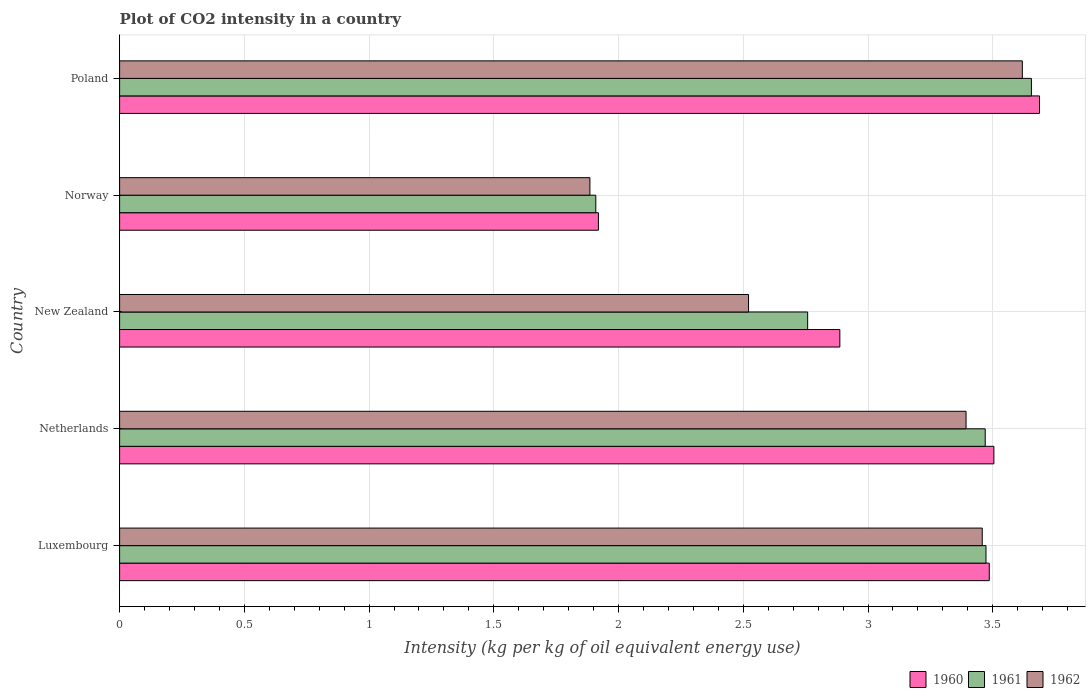How many different coloured bars are there?
Give a very brief answer. 3. How many bars are there on the 3rd tick from the bottom?
Ensure brevity in your answer.  3. What is the label of the 2nd group of bars from the top?
Offer a terse response. Norway. What is the CO2 intensity in in 1960 in New Zealand?
Your response must be concise. 2.89. Across all countries, what is the maximum CO2 intensity in in 1962?
Offer a very short reply. 3.62. Across all countries, what is the minimum CO2 intensity in in 1962?
Offer a very short reply. 1.89. In which country was the CO2 intensity in in 1961 maximum?
Your answer should be very brief. Poland. In which country was the CO2 intensity in in 1962 minimum?
Your answer should be very brief. Norway. What is the total CO2 intensity in in 1961 in the graph?
Give a very brief answer. 15.26. What is the difference between the CO2 intensity in in 1962 in Luxembourg and that in Netherlands?
Offer a terse response. 0.06. What is the difference between the CO2 intensity in in 1961 in New Zealand and the CO2 intensity in in 1960 in Netherlands?
Offer a terse response. -0.75. What is the average CO2 intensity in in 1962 per country?
Ensure brevity in your answer.  2.98. What is the difference between the CO2 intensity in in 1962 and CO2 intensity in in 1960 in Luxembourg?
Your answer should be compact. -0.03. In how many countries, is the CO2 intensity in in 1961 greater than 3.1 kg?
Make the answer very short. 3. What is the ratio of the CO2 intensity in in 1961 in Netherlands to that in New Zealand?
Offer a terse response. 1.26. What is the difference between the highest and the second highest CO2 intensity in in 1960?
Your response must be concise. 0.18. What is the difference between the highest and the lowest CO2 intensity in in 1962?
Provide a short and direct response. 1.73. In how many countries, is the CO2 intensity in in 1961 greater than the average CO2 intensity in in 1961 taken over all countries?
Offer a terse response. 3. What does the 3rd bar from the top in Poland represents?
Give a very brief answer. 1960. What does the 2nd bar from the bottom in Luxembourg represents?
Your answer should be very brief. 1961. Is it the case that in every country, the sum of the CO2 intensity in in 1962 and CO2 intensity in in 1960 is greater than the CO2 intensity in in 1961?
Your answer should be very brief. Yes. How many bars are there?
Keep it short and to the point. 15. Are all the bars in the graph horizontal?
Ensure brevity in your answer.  Yes. Are the values on the major ticks of X-axis written in scientific E-notation?
Make the answer very short. No. Does the graph contain grids?
Your answer should be compact. Yes. How many legend labels are there?
Your answer should be compact. 3. How are the legend labels stacked?
Offer a very short reply. Horizontal. What is the title of the graph?
Ensure brevity in your answer.  Plot of CO2 intensity in a country. What is the label or title of the X-axis?
Your response must be concise. Intensity (kg per kg of oil equivalent energy use). What is the label or title of the Y-axis?
Your answer should be very brief. Country. What is the Intensity (kg per kg of oil equivalent energy use) in 1960 in Luxembourg?
Offer a terse response. 3.49. What is the Intensity (kg per kg of oil equivalent energy use) of 1961 in Luxembourg?
Give a very brief answer. 3.47. What is the Intensity (kg per kg of oil equivalent energy use) of 1962 in Luxembourg?
Provide a short and direct response. 3.46. What is the Intensity (kg per kg of oil equivalent energy use) in 1960 in Netherlands?
Your response must be concise. 3.5. What is the Intensity (kg per kg of oil equivalent energy use) of 1961 in Netherlands?
Provide a short and direct response. 3.47. What is the Intensity (kg per kg of oil equivalent energy use) in 1962 in Netherlands?
Your answer should be very brief. 3.39. What is the Intensity (kg per kg of oil equivalent energy use) of 1960 in New Zealand?
Make the answer very short. 2.89. What is the Intensity (kg per kg of oil equivalent energy use) in 1961 in New Zealand?
Offer a terse response. 2.76. What is the Intensity (kg per kg of oil equivalent energy use) of 1962 in New Zealand?
Your response must be concise. 2.52. What is the Intensity (kg per kg of oil equivalent energy use) in 1960 in Norway?
Your response must be concise. 1.92. What is the Intensity (kg per kg of oil equivalent energy use) of 1961 in Norway?
Ensure brevity in your answer.  1.91. What is the Intensity (kg per kg of oil equivalent energy use) of 1962 in Norway?
Ensure brevity in your answer.  1.89. What is the Intensity (kg per kg of oil equivalent energy use) in 1960 in Poland?
Offer a very short reply. 3.69. What is the Intensity (kg per kg of oil equivalent energy use) of 1961 in Poland?
Your answer should be compact. 3.66. What is the Intensity (kg per kg of oil equivalent energy use) in 1962 in Poland?
Offer a terse response. 3.62. Across all countries, what is the maximum Intensity (kg per kg of oil equivalent energy use) of 1960?
Keep it short and to the point. 3.69. Across all countries, what is the maximum Intensity (kg per kg of oil equivalent energy use) in 1961?
Give a very brief answer. 3.66. Across all countries, what is the maximum Intensity (kg per kg of oil equivalent energy use) of 1962?
Your answer should be compact. 3.62. Across all countries, what is the minimum Intensity (kg per kg of oil equivalent energy use) in 1960?
Your answer should be very brief. 1.92. Across all countries, what is the minimum Intensity (kg per kg of oil equivalent energy use) in 1961?
Your answer should be very brief. 1.91. Across all countries, what is the minimum Intensity (kg per kg of oil equivalent energy use) of 1962?
Make the answer very short. 1.89. What is the total Intensity (kg per kg of oil equivalent energy use) of 1960 in the graph?
Offer a terse response. 15.48. What is the total Intensity (kg per kg of oil equivalent energy use) of 1961 in the graph?
Ensure brevity in your answer.  15.26. What is the total Intensity (kg per kg of oil equivalent energy use) in 1962 in the graph?
Ensure brevity in your answer.  14.88. What is the difference between the Intensity (kg per kg of oil equivalent energy use) in 1960 in Luxembourg and that in Netherlands?
Keep it short and to the point. -0.02. What is the difference between the Intensity (kg per kg of oil equivalent energy use) in 1961 in Luxembourg and that in Netherlands?
Make the answer very short. 0. What is the difference between the Intensity (kg per kg of oil equivalent energy use) in 1962 in Luxembourg and that in Netherlands?
Your answer should be very brief. 0.06. What is the difference between the Intensity (kg per kg of oil equivalent energy use) in 1960 in Luxembourg and that in New Zealand?
Give a very brief answer. 0.6. What is the difference between the Intensity (kg per kg of oil equivalent energy use) in 1961 in Luxembourg and that in New Zealand?
Offer a very short reply. 0.71. What is the difference between the Intensity (kg per kg of oil equivalent energy use) of 1962 in Luxembourg and that in New Zealand?
Provide a succinct answer. 0.94. What is the difference between the Intensity (kg per kg of oil equivalent energy use) in 1960 in Luxembourg and that in Norway?
Provide a short and direct response. 1.57. What is the difference between the Intensity (kg per kg of oil equivalent energy use) of 1961 in Luxembourg and that in Norway?
Keep it short and to the point. 1.56. What is the difference between the Intensity (kg per kg of oil equivalent energy use) in 1962 in Luxembourg and that in Norway?
Keep it short and to the point. 1.57. What is the difference between the Intensity (kg per kg of oil equivalent energy use) in 1960 in Luxembourg and that in Poland?
Keep it short and to the point. -0.2. What is the difference between the Intensity (kg per kg of oil equivalent energy use) of 1961 in Luxembourg and that in Poland?
Provide a short and direct response. -0.18. What is the difference between the Intensity (kg per kg of oil equivalent energy use) in 1962 in Luxembourg and that in Poland?
Your response must be concise. -0.16. What is the difference between the Intensity (kg per kg of oil equivalent energy use) in 1960 in Netherlands and that in New Zealand?
Provide a short and direct response. 0.62. What is the difference between the Intensity (kg per kg of oil equivalent energy use) of 1961 in Netherlands and that in New Zealand?
Your answer should be very brief. 0.71. What is the difference between the Intensity (kg per kg of oil equivalent energy use) of 1962 in Netherlands and that in New Zealand?
Give a very brief answer. 0.87. What is the difference between the Intensity (kg per kg of oil equivalent energy use) in 1960 in Netherlands and that in Norway?
Offer a very short reply. 1.59. What is the difference between the Intensity (kg per kg of oil equivalent energy use) in 1961 in Netherlands and that in Norway?
Provide a short and direct response. 1.56. What is the difference between the Intensity (kg per kg of oil equivalent energy use) of 1962 in Netherlands and that in Norway?
Your answer should be very brief. 1.51. What is the difference between the Intensity (kg per kg of oil equivalent energy use) in 1960 in Netherlands and that in Poland?
Provide a short and direct response. -0.18. What is the difference between the Intensity (kg per kg of oil equivalent energy use) in 1961 in Netherlands and that in Poland?
Offer a very short reply. -0.19. What is the difference between the Intensity (kg per kg of oil equivalent energy use) of 1962 in Netherlands and that in Poland?
Give a very brief answer. -0.23. What is the difference between the Intensity (kg per kg of oil equivalent energy use) of 1960 in New Zealand and that in Norway?
Give a very brief answer. 0.97. What is the difference between the Intensity (kg per kg of oil equivalent energy use) in 1961 in New Zealand and that in Norway?
Offer a terse response. 0.85. What is the difference between the Intensity (kg per kg of oil equivalent energy use) of 1962 in New Zealand and that in Norway?
Your answer should be very brief. 0.64. What is the difference between the Intensity (kg per kg of oil equivalent energy use) in 1960 in New Zealand and that in Poland?
Your answer should be compact. -0.8. What is the difference between the Intensity (kg per kg of oil equivalent energy use) of 1961 in New Zealand and that in Poland?
Provide a succinct answer. -0.9. What is the difference between the Intensity (kg per kg of oil equivalent energy use) of 1962 in New Zealand and that in Poland?
Offer a terse response. -1.1. What is the difference between the Intensity (kg per kg of oil equivalent energy use) in 1960 in Norway and that in Poland?
Your answer should be compact. -1.77. What is the difference between the Intensity (kg per kg of oil equivalent energy use) of 1961 in Norway and that in Poland?
Make the answer very short. -1.75. What is the difference between the Intensity (kg per kg of oil equivalent energy use) of 1962 in Norway and that in Poland?
Offer a terse response. -1.73. What is the difference between the Intensity (kg per kg of oil equivalent energy use) of 1960 in Luxembourg and the Intensity (kg per kg of oil equivalent energy use) of 1961 in Netherlands?
Offer a very short reply. 0.02. What is the difference between the Intensity (kg per kg of oil equivalent energy use) of 1960 in Luxembourg and the Intensity (kg per kg of oil equivalent energy use) of 1962 in Netherlands?
Your response must be concise. 0.09. What is the difference between the Intensity (kg per kg of oil equivalent energy use) of 1961 in Luxembourg and the Intensity (kg per kg of oil equivalent energy use) of 1962 in Netherlands?
Offer a very short reply. 0.08. What is the difference between the Intensity (kg per kg of oil equivalent energy use) of 1960 in Luxembourg and the Intensity (kg per kg of oil equivalent energy use) of 1961 in New Zealand?
Your response must be concise. 0.73. What is the difference between the Intensity (kg per kg of oil equivalent energy use) of 1960 in Luxembourg and the Intensity (kg per kg of oil equivalent energy use) of 1962 in New Zealand?
Provide a short and direct response. 0.96. What is the difference between the Intensity (kg per kg of oil equivalent energy use) of 1961 in Luxembourg and the Intensity (kg per kg of oil equivalent energy use) of 1962 in New Zealand?
Offer a terse response. 0.95. What is the difference between the Intensity (kg per kg of oil equivalent energy use) of 1960 in Luxembourg and the Intensity (kg per kg of oil equivalent energy use) of 1961 in Norway?
Your answer should be very brief. 1.58. What is the difference between the Intensity (kg per kg of oil equivalent energy use) of 1960 in Luxembourg and the Intensity (kg per kg of oil equivalent energy use) of 1962 in Norway?
Provide a succinct answer. 1.6. What is the difference between the Intensity (kg per kg of oil equivalent energy use) of 1961 in Luxembourg and the Intensity (kg per kg of oil equivalent energy use) of 1962 in Norway?
Your response must be concise. 1.59. What is the difference between the Intensity (kg per kg of oil equivalent energy use) in 1960 in Luxembourg and the Intensity (kg per kg of oil equivalent energy use) in 1961 in Poland?
Give a very brief answer. -0.17. What is the difference between the Intensity (kg per kg of oil equivalent energy use) in 1960 in Luxembourg and the Intensity (kg per kg of oil equivalent energy use) in 1962 in Poland?
Make the answer very short. -0.13. What is the difference between the Intensity (kg per kg of oil equivalent energy use) in 1961 in Luxembourg and the Intensity (kg per kg of oil equivalent energy use) in 1962 in Poland?
Give a very brief answer. -0.15. What is the difference between the Intensity (kg per kg of oil equivalent energy use) of 1960 in Netherlands and the Intensity (kg per kg of oil equivalent energy use) of 1961 in New Zealand?
Provide a succinct answer. 0.75. What is the difference between the Intensity (kg per kg of oil equivalent energy use) of 1960 in Netherlands and the Intensity (kg per kg of oil equivalent energy use) of 1962 in New Zealand?
Ensure brevity in your answer.  0.98. What is the difference between the Intensity (kg per kg of oil equivalent energy use) of 1961 in Netherlands and the Intensity (kg per kg of oil equivalent energy use) of 1962 in New Zealand?
Ensure brevity in your answer.  0.95. What is the difference between the Intensity (kg per kg of oil equivalent energy use) of 1960 in Netherlands and the Intensity (kg per kg of oil equivalent energy use) of 1961 in Norway?
Make the answer very short. 1.6. What is the difference between the Intensity (kg per kg of oil equivalent energy use) of 1960 in Netherlands and the Intensity (kg per kg of oil equivalent energy use) of 1962 in Norway?
Give a very brief answer. 1.62. What is the difference between the Intensity (kg per kg of oil equivalent energy use) in 1961 in Netherlands and the Intensity (kg per kg of oil equivalent energy use) in 1962 in Norway?
Your response must be concise. 1.58. What is the difference between the Intensity (kg per kg of oil equivalent energy use) in 1960 in Netherlands and the Intensity (kg per kg of oil equivalent energy use) in 1961 in Poland?
Your response must be concise. -0.15. What is the difference between the Intensity (kg per kg of oil equivalent energy use) of 1960 in Netherlands and the Intensity (kg per kg of oil equivalent energy use) of 1962 in Poland?
Your answer should be compact. -0.11. What is the difference between the Intensity (kg per kg of oil equivalent energy use) in 1961 in Netherlands and the Intensity (kg per kg of oil equivalent energy use) in 1962 in Poland?
Your answer should be very brief. -0.15. What is the difference between the Intensity (kg per kg of oil equivalent energy use) of 1960 in New Zealand and the Intensity (kg per kg of oil equivalent energy use) of 1961 in Norway?
Ensure brevity in your answer.  0.98. What is the difference between the Intensity (kg per kg of oil equivalent energy use) in 1960 in New Zealand and the Intensity (kg per kg of oil equivalent energy use) in 1962 in Norway?
Offer a very short reply. 1. What is the difference between the Intensity (kg per kg of oil equivalent energy use) of 1961 in New Zealand and the Intensity (kg per kg of oil equivalent energy use) of 1962 in Norway?
Offer a terse response. 0.87. What is the difference between the Intensity (kg per kg of oil equivalent energy use) of 1960 in New Zealand and the Intensity (kg per kg of oil equivalent energy use) of 1961 in Poland?
Provide a short and direct response. -0.77. What is the difference between the Intensity (kg per kg of oil equivalent energy use) of 1960 in New Zealand and the Intensity (kg per kg of oil equivalent energy use) of 1962 in Poland?
Your response must be concise. -0.73. What is the difference between the Intensity (kg per kg of oil equivalent energy use) of 1961 in New Zealand and the Intensity (kg per kg of oil equivalent energy use) of 1962 in Poland?
Offer a very short reply. -0.86. What is the difference between the Intensity (kg per kg of oil equivalent energy use) in 1960 in Norway and the Intensity (kg per kg of oil equivalent energy use) in 1961 in Poland?
Keep it short and to the point. -1.74. What is the difference between the Intensity (kg per kg of oil equivalent energy use) in 1960 in Norway and the Intensity (kg per kg of oil equivalent energy use) in 1962 in Poland?
Provide a succinct answer. -1.7. What is the difference between the Intensity (kg per kg of oil equivalent energy use) in 1961 in Norway and the Intensity (kg per kg of oil equivalent energy use) in 1962 in Poland?
Your answer should be compact. -1.71. What is the average Intensity (kg per kg of oil equivalent energy use) in 1960 per country?
Provide a succinct answer. 3.1. What is the average Intensity (kg per kg of oil equivalent energy use) in 1961 per country?
Offer a terse response. 3.05. What is the average Intensity (kg per kg of oil equivalent energy use) of 1962 per country?
Provide a short and direct response. 2.98. What is the difference between the Intensity (kg per kg of oil equivalent energy use) of 1960 and Intensity (kg per kg of oil equivalent energy use) of 1961 in Luxembourg?
Give a very brief answer. 0.01. What is the difference between the Intensity (kg per kg of oil equivalent energy use) of 1960 and Intensity (kg per kg of oil equivalent energy use) of 1962 in Luxembourg?
Offer a very short reply. 0.03. What is the difference between the Intensity (kg per kg of oil equivalent energy use) of 1961 and Intensity (kg per kg of oil equivalent energy use) of 1962 in Luxembourg?
Keep it short and to the point. 0.01. What is the difference between the Intensity (kg per kg of oil equivalent energy use) of 1960 and Intensity (kg per kg of oil equivalent energy use) of 1961 in Netherlands?
Provide a short and direct response. 0.03. What is the difference between the Intensity (kg per kg of oil equivalent energy use) in 1960 and Intensity (kg per kg of oil equivalent energy use) in 1962 in Netherlands?
Your answer should be compact. 0.11. What is the difference between the Intensity (kg per kg of oil equivalent energy use) in 1961 and Intensity (kg per kg of oil equivalent energy use) in 1962 in Netherlands?
Offer a terse response. 0.08. What is the difference between the Intensity (kg per kg of oil equivalent energy use) of 1960 and Intensity (kg per kg of oil equivalent energy use) of 1961 in New Zealand?
Your response must be concise. 0.13. What is the difference between the Intensity (kg per kg of oil equivalent energy use) of 1960 and Intensity (kg per kg of oil equivalent energy use) of 1962 in New Zealand?
Offer a very short reply. 0.37. What is the difference between the Intensity (kg per kg of oil equivalent energy use) in 1961 and Intensity (kg per kg of oil equivalent energy use) in 1962 in New Zealand?
Keep it short and to the point. 0.24. What is the difference between the Intensity (kg per kg of oil equivalent energy use) of 1960 and Intensity (kg per kg of oil equivalent energy use) of 1961 in Norway?
Your answer should be compact. 0.01. What is the difference between the Intensity (kg per kg of oil equivalent energy use) in 1960 and Intensity (kg per kg of oil equivalent energy use) in 1962 in Norway?
Provide a short and direct response. 0.03. What is the difference between the Intensity (kg per kg of oil equivalent energy use) of 1961 and Intensity (kg per kg of oil equivalent energy use) of 1962 in Norway?
Your response must be concise. 0.02. What is the difference between the Intensity (kg per kg of oil equivalent energy use) of 1960 and Intensity (kg per kg of oil equivalent energy use) of 1961 in Poland?
Offer a terse response. 0.03. What is the difference between the Intensity (kg per kg of oil equivalent energy use) of 1960 and Intensity (kg per kg of oil equivalent energy use) of 1962 in Poland?
Provide a short and direct response. 0.07. What is the difference between the Intensity (kg per kg of oil equivalent energy use) of 1961 and Intensity (kg per kg of oil equivalent energy use) of 1962 in Poland?
Ensure brevity in your answer.  0.04. What is the ratio of the Intensity (kg per kg of oil equivalent energy use) of 1960 in Luxembourg to that in Netherlands?
Your response must be concise. 0.99. What is the ratio of the Intensity (kg per kg of oil equivalent energy use) of 1962 in Luxembourg to that in Netherlands?
Provide a short and direct response. 1.02. What is the ratio of the Intensity (kg per kg of oil equivalent energy use) in 1960 in Luxembourg to that in New Zealand?
Keep it short and to the point. 1.21. What is the ratio of the Intensity (kg per kg of oil equivalent energy use) in 1961 in Luxembourg to that in New Zealand?
Offer a terse response. 1.26. What is the ratio of the Intensity (kg per kg of oil equivalent energy use) in 1962 in Luxembourg to that in New Zealand?
Your answer should be very brief. 1.37. What is the ratio of the Intensity (kg per kg of oil equivalent energy use) in 1960 in Luxembourg to that in Norway?
Offer a very short reply. 1.82. What is the ratio of the Intensity (kg per kg of oil equivalent energy use) in 1961 in Luxembourg to that in Norway?
Ensure brevity in your answer.  1.82. What is the ratio of the Intensity (kg per kg of oil equivalent energy use) in 1962 in Luxembourg to that in Norway?
Make the answer very short. 1.83. What is the ratio of the Intensity (kg per kg of oil equivalent energy use) of 1960 in Luxembourg to that in Poland?
Offer a terse response. 0.95. What is the ratio of the Intensity (kg per kg of oil equivalent energy use) of 1961 in Luxembourg to that in Poland?
Provide a short and direct response. 0.95. What is the ratio of the Intensity (kg per kg of oil equivalent energy use) of 1962 in Luxembourg to that in Poland?
Provide a succinct answer. 0.96. What is the ratio of the Intensity (kg per kg of oil equivalent energy use) in 1960 in Netherlands to that in New Zealand?
Make the answer very short. 1.21. What is the ratio of the Intensity (kg per kg of oil equivalent energy use) of 1961 in Netherlands to that in New Zealand?
Your answer should be compact. 1.26. What is the ratio of the Intensity (kg per kg of oil equivalent energy use) of 1962 in Netherlands to that in New Zealand?
Your answer should be very brief. 1.35. What is the ratio of the Intensity (kg per kg of oil equivalent energy use) in 1960 in Netherlands to that in Norway?
Your answer should be compact. 1.83. What is the ratio of the Intensity (kg per kg of oil equivalent energy use) of 1961 in Netherlands to that in Norway?
Your answer should be very brief. 1.82. What is the ratio of the Intensity (kg per kg of oil equivalent energy use) of 1962 in Netherlands to that in Norway?
Provide a short and direct response. 1.8. What is the ratio of the Intensity (kg per kg of oil equivalent energy use) of 1960 in Netherlands to that in Poland?
Make the answer very short. 0.95. What is the ratio of the Intensity (kg per kg of oil equivalent energy use) in 1961 in Netherlands to that in Poland?
Provide a short and direct response. 0.95. What is the ratio of the Intensity (kg per kg of oil equivalent energy use) in 1962 in Netherlands to that in Poland?
Offer a very short reply. 0.94. What is the ratio of the Intensity (kg per kg of oil equivalent energy use) of 1960 in New Zealand to that in Norway?
Provide a short and direct response. 1.5. What is the ratio of the Intensity (kg per kg of oil equivalent energy use) of 1961 in New Zealand to that in Norway?
Your answer should be very brief. 1.44. What is the ratio of the Intensity (kg per kg of oil equivalent energy use) in 1962 in New Zealand to that in Norway?
Your response must be concise. 1.34. What is the ratio of the Intensity (kg per kg of oil equivalent energy use) in 1960 in New Zealand to that in Poland?
Offer a terse response. 0.78. What is the ratio of the Intensity (kg per kg of oil equivalent energy use) of 1961 in New Zealand to that in Poland?
Your answer should be compact. 0.75. What is the ratio of the Intensity (kg per kg of oil equivalent energy use) in 1962 in New Zealand to that in Poland?
Provide a succinct answer. 0.7. What is the ratio of the Intensity (kg per kg of oil equivalent energy use) of 1960 in Norway to that in Poland?
Offer a terse response. 0.52. What is the ratio of the Intensity (kg per kg of oil equivalent energy use) in 1961 in Norway to that in Poland?
Give a very brief answer. 0.52. What is the ratio of the Intensity (kg per kg of oil equivalent energy use) in 1962 in Norway to that in Poland?
Your answer should be very brief. 0.52. What is the difference between the highest and the second highest Intensity (kg per kg of oil equivalent energy use) in 1960?
Provide a short and direct response. 0.18. What is the difference between the highest and the second highest Intensity (kg per kg of oil equivalent energy use) of 1961?
Your answer should be compact. 0.18. What is the difference between the highest and the second highest Intensity (kg per kg of oil equivalent energy use) of 1962?
Your answer should be compact. 0.16. What is the difference between the highest and the lowest Intensity (kg per kg of oil equivalent energy use) of 1960?
Make the answer very short. 1.77. What is the difference between the highest and the lowest Intensity (kg per kg of oil equivalent energy use) of 1961?
Offer a terse response. 1.75. What is the difference between the highest and the lowest Intensity (kg per kg of oil equivalent energy use) in 1962?
Provide a succinct answer. 1.73. 